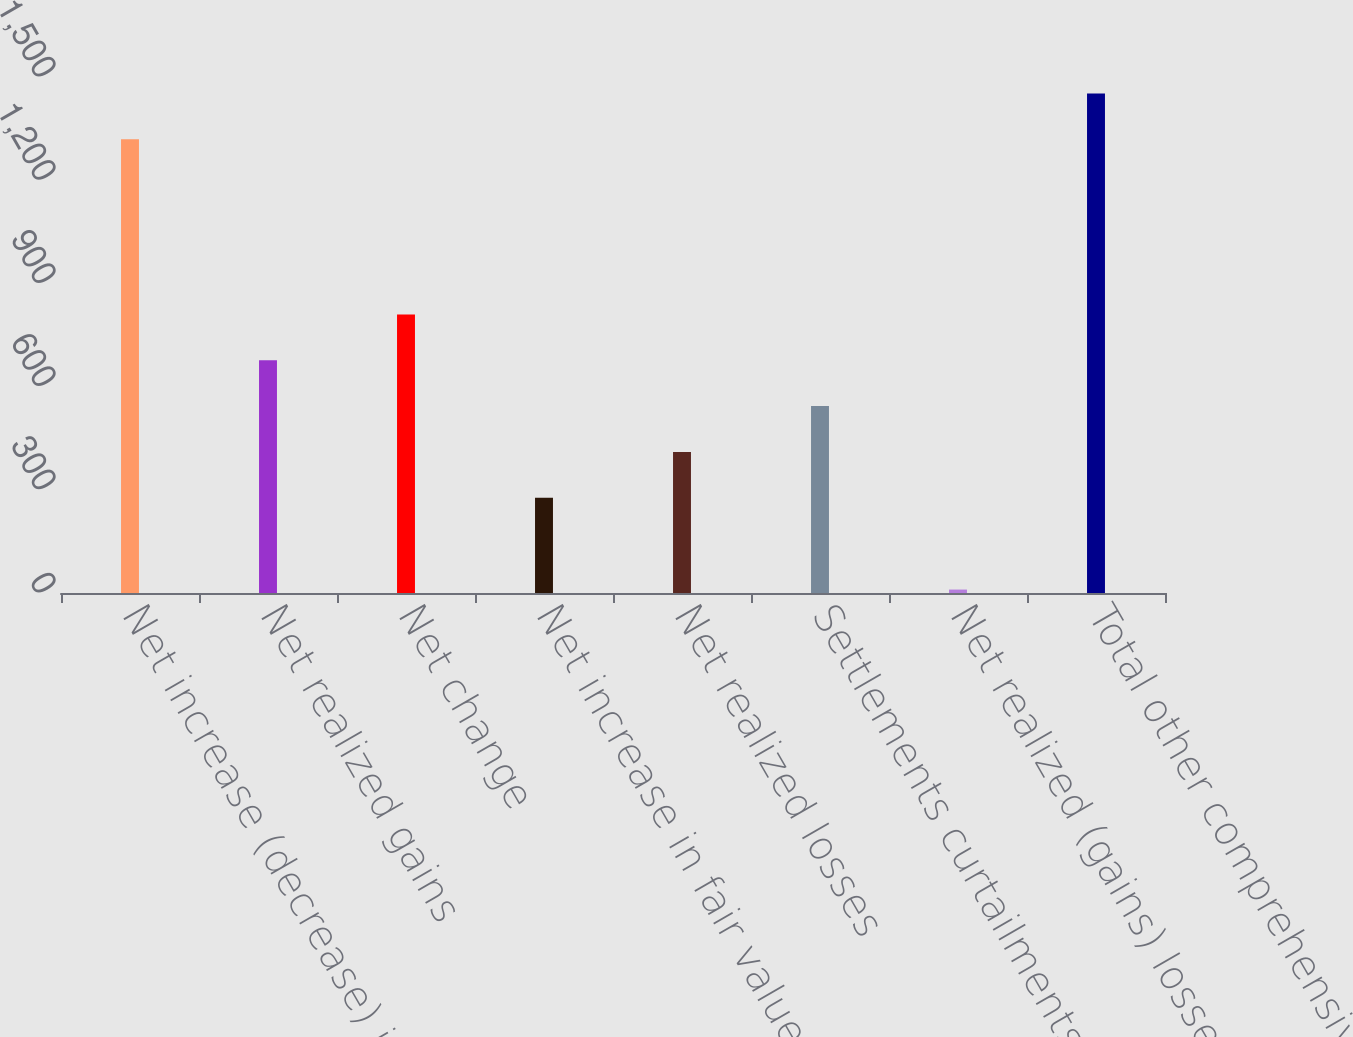<chart> <loc_0><loc_0><loc_500><loc_500><bar_chart><fcel>Net increase (decrease) in<fcel>Net realized gains<fcel>Net change<fcel>Net increase in fair value<fcel>Net realized losses<fcel>Settlements curtailments and<fcel>Net realized (gains) losses<fcel>Total other comprehensive<nl><fcel>1319<fcel>676.6<fcel>809.8<fcel>277<fcel>410.2<fcel>543.4<fcel>10<fcel>1452.2<nl></chart> 